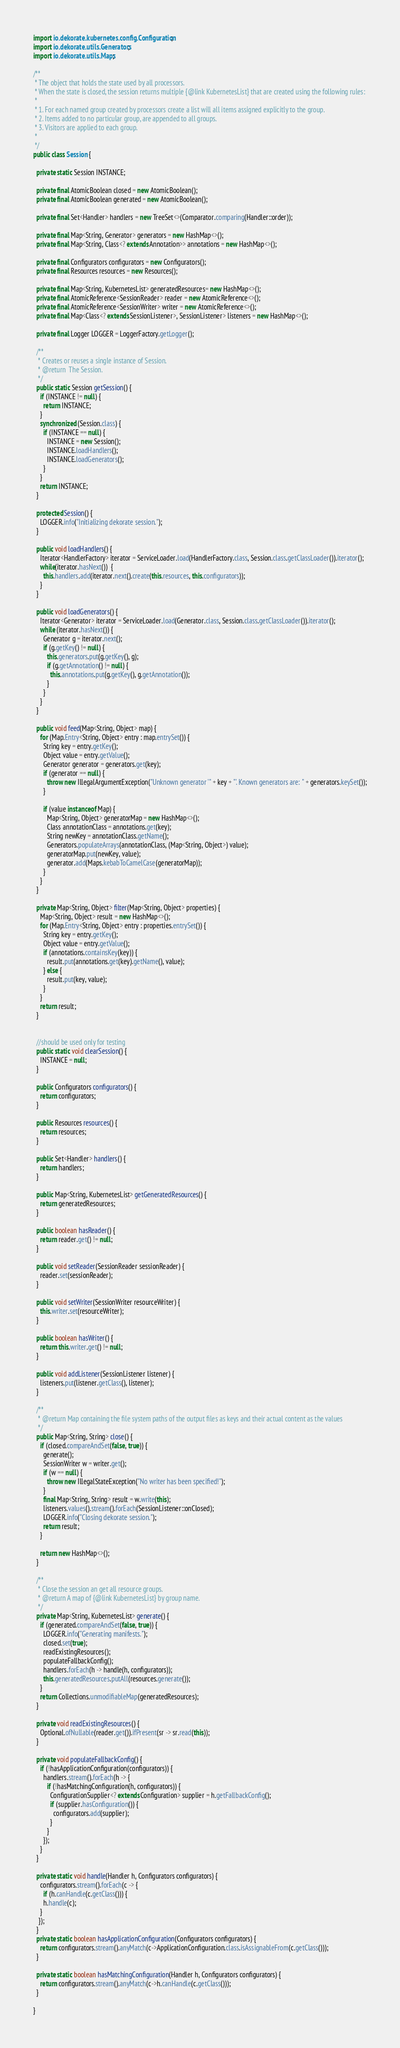Convert code to text. <code><loc_0><loc_0><loc_500><loc_500><_Java_>import io.dekorate.kubernetes.config.Configuration;
import io.dekorate.utils.Generators;
import io.dekorate.utils.Maps;

/**
 * The object that holds the state used by all processors.
 * When the state is closed, the session returns multiple {@link KubernetesList} that are created using the following rules:
 *
 * 1. For each named group created by processors create a list will all items assigned explicitly to the group.
 * 2. Items added to no particular group, are appended to all groups.
 * 3. Visitors are applied to each group.
 *
 */
public class Session {

  private static Session INSTANCE;

  private final AtomicBoolean closed = new AtomicBoolean();
  private final AtomicBoolean generated = new AtomicBoolean();

  private final Set<Handler> handlers = new TreeSet<>(Comparator.comparing(Handler::order));

  private final Map<String, Generator> generators = new HashMap<>();
  private final Map<String, Class<? extends Annotation>> annotations = new HashMap<>();

  private final Configurators configurators = new Configurators();
  private final Resources resources = new Resources();

  private final Map<String, KubernetesList> generatedResources= new HashMap<>();
  private final AtomicReference<SessionReader> reader = new AtomicReference<>();
  private final AtomicReference<SessionWriter> writer = new AtomicReference<>();
  private final Map<Class<? extends SessionListener>, SessionListener> listeners = new HashMap<>();

  private final Logger LOGGER = LoggerFactory.getLogger();

  /**
   * Creates or reuses a single instance of Session.
   * @return  The Session.
   */
  public static Session getSession() {
    if (INSTANCE != null) {
      return INSTANCE;
    }
    synchronized (Session.class) {
      if (INSTANCE == null) {
        INSTANCE = new Session();
        INSTANCE.loadHandlers();
        INSTANCE.loadGenerators();
      }
    }
    return INSTANCE;
  }

  protected Session() {
    LOGGER.info("Initializing dekorate session.");
  }

  public void loadHandlers() {
    Iterator<HandlerFactory> iterator = ServiceLoader.load(HandlerFactory.class, Session.class.getClassLoader()).iterator();
    while(iterator.hasNext())  {
      this.handlers.add(iterator.next().create(this.resources, this.configurators));
    }
  }

  public void loadGenerators() {
    Iterator<Generator> iterator = ServiceLoader.load(Generator.class, Session.class.getClassLoader()).iterator();
    while (iterator.hasNext()) {
      Generator g = iterator.next();
      if (g.getKey() != null) {
        this.generators.put(g.getKey(), g);
        if (g.getAnnotation() != null) {
          this.annotations.put(g.getKey(), g.getAnnotation());
        }
      }
    }
  }

  public void feed(Map<String, Object> map) {
    for (Map.Entry<String, Object> entry : map.entrySet()) {
      String key = entry.getKey();
      Object value = entry.getValue();
      Generator generator = generators.get(key);
      if (generator == null) {
        throw new IllegalArgumentException("Unknown generator '" + key + "'. Known generators are: " + generators.keySet());
      }

      if (value instanceof Map) {
        Map<String, Object> generatorMap = new HashMap<>();
        Class annotationClass = annotations.get(key);
        String newKey = annotationClass.getName();
        Generators.populateArrays(annotationClass, (Map<String, Object>) value);
        generatorMap.put(newKey, value);
        generator.add(Maps.kebabToCamelCase(generatorMap));
      }
    }
  }

  private Map<String, Object> filter(Map<String, Object> properties) {
    Map<String, Object> result = new HashMap<>();
    for (Map.Entry<String, Object> entry : properties.entrySet()) {
      String key = entry.getKey();
      Object value = entry.getValue();
      if (annotations.containsKey(key)) {
        result.put(annotations.get(key).getName(), value);
      } else {
        result.put(key, value);
      }
    }
    return result;
  }


  //should be used only for testing
  public static void clearSession() {
    INSTANCE = null;
  }

  public Configurators configurators() {
    return configurators;
  }

  public Resources resources() {
    return resources;
  }

  public Set<Handler> handlers() {
    return handlers;
  }

  public Map<String, KubernetesList> getGeneratedResources() {
    return generatedResources;
  }

  public boolean hasReader() {
    return reader.get() != null;
  }

  public void setReader(SessionReader sessionReader) {
    reader.set(sessionReader);
  }

  public void setWriter(SessionWriter resourceWriter) {
    this.writer.set(resourceWriter);
  }

  public boolean hasWriter() {
    return this.writer.get() != null;
  }

  public void addListener(SessionListener listener) {
    listeners.put(listener.getClass(), listener);
  }

  /**
   * @return Map containing the file system paths of the output files as keys and their actual content as the values
   */
  public Map<String, String> close() {
    if (closed.compareAndSet(false, true)) {
      generate();
      SessionWriter w = writer.get();
      if (w == null) {
        throw new IllegalStateException("No writer has been specified!");
      }
      final Map<String, String> result = w.write(this);
      listeners.values().stream().forEach(SessionListener::onClosed);
      LOGGER.info("Closing dekorate session.");
      return result;
    }

    return new HashMap<>();
  }

  /**
   * Close the session an get all resource groups.
   * @return A map of {@link KubernetesList} by group name.
   */
  private Map<String, KubernetesList> generate() {
    if (generated.compareAndSet(false, true)) {
      LOGGER.info("Generating manifests.");
      closed.set(true);
      readExistingResources();
      populateFallbackConfig();
      handlers.forEach(h -> handle(h, configurators));
      this.generatedResources.putAll(resources.generate());
    }
    return Collections.unmodifiableMap(generatedResources);
  }

  private void readExistingResources() {
    Optional.ofNullable(reader.get()).ifPresent(sr -> sr.read(this));
  }

  private void populateFallbackConfig() {
    if (!hasApplicationConfiguration(configurators)) {
      handlers.stream().forEach(h -> {
        if (!hasMatchingConfiguration(h, configurators)) {
          ConfigurationSupplier<? extends Configuration> supplier = h.getFallbackConfig();
          if (supplier.hasConfiguration()) {
            configurators.add(supplier);
          }
        }
      });
    }
  }

  private static void handle(Handler h, Configurators configurators) {
    configurators.stream().forEach(c -> {
      if (h.canHandle(c.getClass())) {
      h.handle(c);
    }
   });
  }
  private static boolean hasApplicationConfiguration(Configurators configurators) {
    return configurators.stream().anyMatch(c->ApplicationConfiguration.class.isAssignableFrom(c.getClass()));
  }

  private static boolean hasMatchingConfiguration(Handler h, Configurators configurators) {
    return configurators.stream().anyMatch(c->h.canHandle(c.getClass()));
  }

}
</code> 